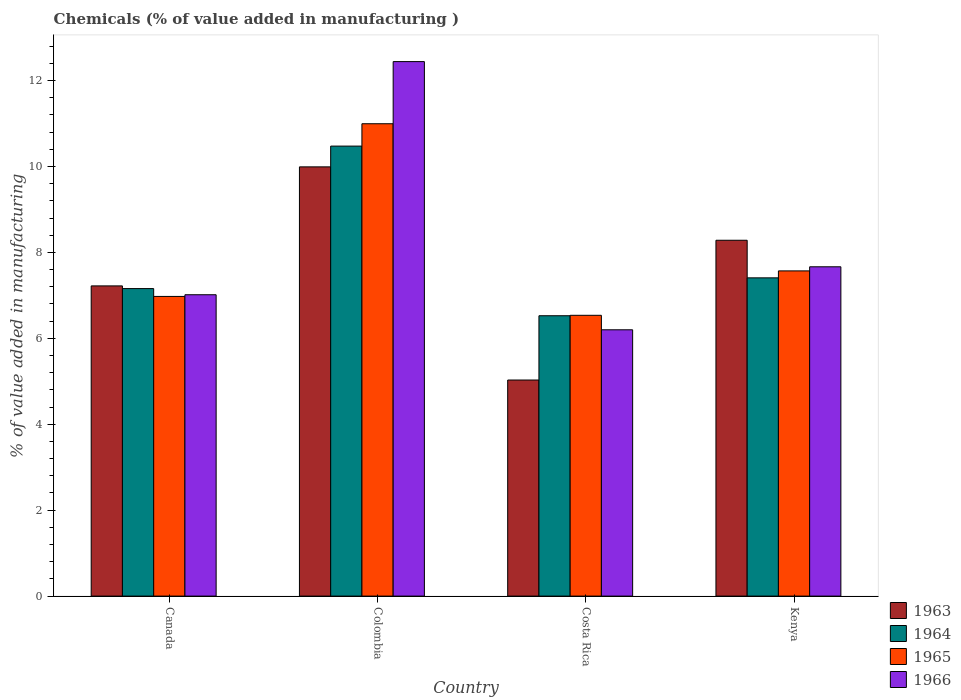How many groups of bars are there?
Keep it short and to the point. 4. How many bars are there on the 1st tick from the left?
Offer a terse response. 4. How many bars are there on the 1st tick from the right?
Your response must be concise. 4. What is the label of the 1st group of bars from the left?
Keep it short and to the point. Canada. What is the value added in manufacturing chemicals in 1964 in Colombia?
Your answer should be compact. 10.47. Across all countries, what is the maximum value added in manufacturing chemicals in 1966?
Provide a short and direct response. 12.44. Across all countries, what is the minimum value added in manufacturing chemicals in 1963?
Give a very brief answer. 5.03. In which country was the value added in manufacturing chemicals in 1964 maximum?
Provide a short and direct response. Colombia. In which country was the value added in manufacturing chemicals in 1963 minimum?
Give a very brief answer. Costa Rica. What is the total value added in manufacturing chemicals in 1966 in the graph?
Offer a very short reply. 33.32. What is the difference between the value added in manufacturing chemicals in 1964 in Canada and that in Colombia?
Make the answer very short. -3.32. What is the difference between the value added in manufacturing chemicals in 1966 in Costa Rica and the value added in manufacturing chemicals in 1965 in Colombia?
Make the answer very short. -4.8. What is the average value added in manufacturing chemicals in 1966 per country?
Provide a short and direct response. 8.33. What is the difference between the value added in manufacturing chemicals of/in 1964 and value added in manufacturing chemicals of/in 1963 in Canada?
Keep it short and to the point. -0.06. In how many countries, is the value added in manufacturing chemicals in 1964 greater than 3.2 %?
Your answer should be compact. 4. What is the ratio of the value added in manufacturing chemicals in 1964 in Colombia to that in Costa Rica?
Your response must be concise. 1.61. What is the difference between the highest and the second highest value added in manufacturing chemicals in 1963?
Your answer should be compact. -1.71. What is the difference between the highest and the lowest value added in manufacturing chemicals in 1966?
Provide a succinct answer. 6.24. In how many countries, is the value added in manufacturing chemicals in 1964 greater than the average value added in manufacturing chemicals in 1964 taken over all countries?
Your answer should be compact. 1. What does the 3rd bar from the left in Costa Rica represents?
Give a very brief answer. 1965. Where does the legend appear in the graph?
Give a very brief answer. Bottom right. What is the title of the graph?
Keep it short and to the point. Chemicals (% of value added in manufacturing ). What is the label or title of the X-axis?
Offer a terse response. Country. What is the label or title of the Y-axis?
Your answer should be compact. % of value added in manufacturing. What is the % of value added in manufacturing of 1963 in Canada?
Your response must be concise. 7.22. What is the % of value added in manufacturing of 1964 in Canada?
Keep it short and to the point. 7.16. What is the % of value added in manufacturing of 1965 in Canada?
Your answer should be very brief. 6.98. What is the % of value added in manufacturing in 1966 in Canada?
Offer a very short reply. 7.01. What is the % of value added in manufacturing of 1963 in Colombia?
Offer a very short reply. 9.99. What is the % of value added in manufacturing of 1964 in Colombia?
Your answer should be very brief. 10.47. What is the % of value added in manufacturing of 1965 in Colombia?
Your answer should be very brief. 10.99. What is the % of value added in manufacturing of 1966 in Colombia?
Keep it short and to the point. 12.44. What is the % of value added in manufacturing of 1963 in Costa Rica?
Your response must be concise. 5.03. What is the % of value added in manufacturing of 1964 in Costa Rica?
Your answer should be compact. 6.53. What is the % of value added in manufacturing in 1965 in Costa Rica?
Offer a very short reply. 6.54. What is the % of value added in manufacturing of 1966 in Costa Rica?
Your answer should be compact. 6.2. What is the % of value added in manufacturing in 1963 in Kenya?
Provide a short and direct response. 8.28. What is the % of value added in manufacturing in 1964 in Kenya?
Your answer should be very brief. 7.41. What is the % of value added in manufacturing in 1965 in Kenya?
Give a very brief answer. 7.57. What is the % of value added in manufacturing in 1966 in Kenya?
Give a very brief answer. 7.67. Across all countries, what is the maximum % of value added in manufacturing of 1963?
Make the answer very short. 9.99. Across all countries, what is the maximum % of value added in manufacturing of 1964?
Your answer should be compact. 10.47. Across all countries, what is the maximum % of value added in manufacturing in 1965?
Your response must be concise. 10.99. Across all countries, what is the maximum % of value added in manufacturing of 1966?
Your answer should be compact. 12.44. Across all countries, what is the minimum % of value added in manufacturing in 1963?
Make the answer very short. 5.03. Across all countries, what is the minimum % of value added in manufacturing in 1964?
Your answer should be very brief. 6.53. Across all countries, what is the minimum % of value added in manufacturing of 1965?
Your answer should be very brief. 6.54. Across all countries, what is the minimum % of value added in manufacturing in 1966?
Provide a short and direct response. 6.2. What is the total % of value added in manufacturing of 1963 in the graph?
Keep it short and to the point. 30.52. What is the total % of value added in manufacturing of 1964 in the graph?
Make the answer very short. 31.57. What is the total % of value added in manufacturing of 1965 in the graph?
Keep it short and to the point. 32.08. What is the total % of value added in manufacturing in 1966 in the graph?
Make the answer very short. 33.32. What is the difference between the % of value added in manufacturing in 1963 in Canada and that in Colombia?
Make the answer very short. -2.77. What is the difference between the % of value added in manufacturing of 1964 in Canada and that in Colombia?
Your answer should be very brief. -3.32. What is the difference between the % of value added in manufacturing of 1965 in Canada and that in Colombia?
Ensure brevity in your answer.  -4.02. What is the difference between the % of value added in manufacturing of 1966 in Canada and that in Colombia?
Make the answer very short. -5.43. What is the difference between the % of value added in manufacturing of 1963 in Canada and that in Costa Rica?
Make the answer very short. 2.19. What is the difference between the % of value added in manufacturing of 1964 in Canada and that in Costa Rica?
Ensure brevity in your answer.  0.63. What is the difference between the % of value added in manufacturing of 1965 in Canada and that in Costa Rica?
Your answer should be very brief. 0.44. What is the difference between the % of value added in manufacturing of 1966 in Canada and that in Costa Rica?
Your answer should be very brief. 0.82. What is the difference between the % of value added in manufacturing in 1963 in Canada and that in Kenya?
Your answer should be compact. -1.06. What is the difference between the % of value added in manufacturing of 1964 in Canada and that in Kenya?
Provide a short and direct response. -0.25. What is the difference between the % of value added in manufacturing in 1965 in Canada and that in Kenya?
Your answer should be very brief. -0.59. What is the difference between the % of value added in manufacturing in 1966 in Canada and that in Kenya?
Ensure brevity in your answer.  -0.65. What is the difference between the % of value added in manufacturing in 1963 in Colombia and that in Costa Rica?
Your answer should be very brief. 4.96. What is the difference between the % of value added in manufacturing in 1964 in Colombia and that in Costa Rica?
Provide a succinct answer. 3.95. What is the difference between the % of value added in manufacturing in 1965 in Colombia and that in Costa Rica?
Ensure brevity in your answer.  4.46. What is the difference between the % of value added in manufacturing in 1966 in Colombia and that in Costa Rica?
Your answer should be compact. 6.24. What is the difference between the % of value added in manufacturing of 1963 in Colombia and that in Kenya?
Make the answer very short. 1.71. What is the difference between the % of value added in manufacturing in 1964 in Colombia and that in Kenya?
Give a very brief answer. 3.07. What is the difference between the % of value added in manufacturing of 1965 in Colombia and that in Kenya?
Your answer should be very brief. 3.43. What is the difference between the % of value added in manufacturing in 1966 in Colombia and that in Kenya?
Give a very brief answer. 4.78. What is the difference between the % of value added in manufacturing of 1963 in Costa Rica and that in Kenya?
Your answer should be very brief. -3.25. What is the difference between the % of value added in manufacturing of 1964 in Costa Rica and that in Kenya?
Your response must be concise. -0.88. What is the difference between the % of value added in manufacturing of 1965 in Costa Rica and that in Kenya?
Your answer should be compact. -1.03. What is the difference between the % of value added in manufacturing of 1966 in Costa Rica and that in Kenya?
Ensure brevity in your answer.  -1.47. What is the difference between the % of value added in manufacturing of 1963 in Canada and the % of value added in manufacturing of 1964 in Colombia?
Provide a short and direct response. -3.25. What is the difference between the % of value added in manufacturing of 1963 in Canada and the % of value added in manufacturing of 1965 in Colombia?
Provide a succinct answer. -3.77. What is the difference between the % of value added in manufacturing of 1963 in Canada and the % of value added in manufacturing of 1966 in Colombia?
Give a very brief answer. -5.22. What is the difference between the % of value added in manufacturing of 1964 in Canada and the % of value added in manufacturing of 1965 in Colombia?
Keep it short and to the point. -3.84. What is the difference between the % of value added in manufacturing of 1964 in Canada and the % of value added in manufacturing of 1966 in Colombia?
Your answer should be compact. -5.28. What is the difference between the % of value added in manufacturing in 1965 in Canada and the % of value added in manufacturing in 1966 in Colombia?
Provide a short and direct response. -5.47. What is the difference between the % of value added in manufacturing of 1963 in Canada and the % of value added in manufacturing of 1964 in Costa Rica?
Your answer should be very brief. 0.69. What is the difference between the % of value added in manufacturing in 1963 in Canada and the % of value added in manufacturing in 1965 in Costa Rica?
Your answer should be compact. 0.68. What is the difference between the % of value added in manufacturing in 1963 in Canada and the % of value added in manufacturing in 1966 in Costa Rica?
Provide a succinct answer. 1.02. What is the difference between the % of value added in manufacturing in 1964 in Canada and the % of value added in manufacturing in 1965 in Costa Rica?
Offer a terse response. 0.62. What is the difference between the % of value added in manufacturing in 1964 in Canada and the % of value added in manufacturing in 1966 in Costa Rica?
Your response must be concise. 0.96. What is the difference between the % of value added in manufacturing of 1965 in Canada and the % of value added in manufacturing of 1966 in Costa Rica?
Make the answer very short. 0.78. What is the difference between the % of value added in manufacturing of 1963 in Canada and the % of value added in manufacturing of 1964 in Kenya?
Your answer should be very brief. -0.19. What is the difference between the % of value added in manufacturing in 1963 in Canada and the % of value added in manufacturing in 1965 in Kenya?
Keep it short and to the point. -0.35. What is the difference between the % of value added in manufacturing of 1963 in Canada and the % of value added in manufacturing of 1966 in Kenya?
Your answer should be compact. -0.44. What is the difference between the % of value added in manufacturing of 1964 in Canada and the % of value added in manufacturing of 1965 in Kenya?
Provide a short and direct response. -0.41. What is the difference between the % of value added in manufacturing in 1964 in Canada and the % of value added in manufacturing in 1966 in Kenya?
Ensure brevity in your answer.  -0.51. What is the difference between the % of value added in manufacturing of 1965 in Canada and the % of value added in manufacturing of 1966 in Kenya?
Give a very brief answer. -0.69. What is the difference between the % of value added in manufacturing of 1963 in Colombia and the % of value added in manufacturing of 1964 in Costa Rica?
Offer a very short reply. 3.47. What is the difference between the % of value added in manufacturing of 1963 in Colombia and the % of value added in manufacturing of 1965 in Costa Rica?
Provide a short and direct response. 3.46. What is the difference between the % of value added in manufacturing of 1963 in Colombia and the % of value added in manufacturing of 1966 in Costa Rica?
Give a very brief answer. 3.79. What is the difference between the % of value added in manufacturing of 1964 in Colombia and the % of value added in manufacturing of 1965 in Costa Rica?
Ensure brevity in your answer.  3.94. What is the difference between the % of value added in manufacturing of 1964 in Colombia and the % of value added in manufacturing of 1966 in Costa Rica?
Provide a succinct answer. 4.28. What is the difference between the % of value added in manufacturing in 1965 in Colombia and the % of value added in manufacturing in 1966 in Costa Rica?
Your answer should be very brief. 4.8. What is the difference between the % of value added in manufacturing of 1963 in Colombia and the % of value added in manufacturing of 1964 in Kenya?
Your answer should be very brief. 2.58. What is the difference between the % of value added in manufacturing of 1963 in Colombia and the % of value added in manufacturing of 1965 in Kenya?
Make the answer very short. 2.42. What is the difference between the % of value added in manufacturing in 1963 in Colombia and the % of value added in manufacturing in 1966 in Kenya?
Provide a short and direct response. 2.33. What is the difference between the % of value added in manufacturing of 1964 in Colombia and the % of value added in manufacturing of 1965 in Kenya?
Your response must be concise. 2.9. What is the difference between the % of value added in manufacturing in 1964 in Colombia and the % of value added in manufacturing in 1966 in Kenya?
Your response must be concise. 2.81. What is the difference between the % of value added in manufacturing of 1965 in Colombia and the % of value added in manufacturing of 1966 in Kenya?
Make the answer very short. 3.33. What is the difference between the % of value added in manufacturing of 1963 in Costa Rica and the % of value added in manufacturing of 1964 in Kenya?
Your response must be concise. -2.38. What is the difference between the % of value added in manufacturing of 1963 in Costa Rica and the % of value added in manufacturing of 1965 in Kenya?
Your answer should be very brief. -2.54. What is the difference between the % of value added in manufacturing in 1963 in Costa Rica and the % of value added in manufacturing in 1966 in Kenya?
Provide a short and direct response. -2.64. What is the difference between the % of value added in manufacturing of 1964 in Costa Rica and the % of value added in manufacturing of 1965 in Kenya?
Keep it short and to the point. -1.04. What is the difference between the % of value added in manufacturing of 1964 in Costa Rica and the % of value added in manufacturing of 1966 in Kenya?
Keep it short and to the point. -1.14. What is the difference between the % of value added in manufacturing of 1965 in Costa Rica and the % of value added in manufacturing of 1966 in Kenya?
Your response must be concise. -1.13. What is the average % of value added in manufacturing of 1963 per country?
Give a very brief answer. 7.63. What is the average % of value added in manufacturing of 1964 per country?
Your answer should be very brief. 7.89. What is the average % of value added in manufacturing of 1965 per country?
Keep it short and to the point. 8.02. What is the average % of value added in manufacturing in 1966 per country?
Keep it short and to the point. 8.33. What is the difference between the % of value added in manufacturing in 1963 and % of value added in manufacturing in 1964 in Canada?
Provide a succinct answer. 0.06. What is the difference between the % of value added in manufacturing in 1963 and % of value added in manufacturing in 1965 in Canada?
Provide a short and direct response. 0.25. What is the difference between the % of value added in manufacturing in 1963 and % of value added in manufacturing in 1966 in Canada?
Provide a short and direct response. 0.21. What is the difference between the % of value added in manufacturing of 1964 and % of value added in manufacturing of 1965 in Canada?
Your response must be concise. 0.18. What is the difference between the % of value added in manufacturing in 1964 and % of value added in manufacturing in 1966 in Canada?
Offer a terse response. 0.14. What is the difference between the % of value added in manufacturing of 1965 and % of value added in manufacturing of 1966 in Canada?
Offer a terse response. -0.04. What is the difference between the % of value added in manufacturing of 1963 and % of value added in manufacturing of 1964 in Colombia?
Offer a terse response. -0.48. What is the difference between the % of value added in manufacturing in 1963 and % of value added in manufacturing in 1965 in Colombia?
Your response must be concise. -1. What is the difference between the % of value added in manufacturing of 1963 and % of value added in manufacturing of 1966 in Colombia?
Make the answer very short. -2.45. What is the difference between the % of value added in manufacturing of 1964 and % of value added in manufacturing of 1965 in Colombia?
Provide a succinct answer. -0.52. What is the difference between the % of value added in manufacturing in 1964 and % of value added in manufacturing in 1966 in Colombia?
Provide a short and direct response. -1.97. What is the difference between the % of value added in manufacturing of 1965 and % of value added in manufacturing of 1966 in Colombia?
Your answer should be compact. -1.45. What is the difference between the % of value added in manufacturing of 1963 and % of value added in manufacturing of 1964 in Costa Rica?
Provide a short and direct response. -1.5. What is the difference between the % of value added in manufacturing of 1963 and % of value added in manufacturing of 1965 in Costa Rica?
Keep it short and to the point. -1.51. What is the difference between the % of value added in manufacturing in 1963 and % of value added in manufacturing in 1966 in Costa Rica?
Offer a very short reply. -1.17. What is the difference between the % of value added in manufacturing of 1964 and % of value added in manufacturing of 1965 in Costa Rica?
Ensure brevity in your answer.  -0.01. What is the difference between the % of value added in manufacturing in 1964 and % of value added in manufacturing in 1966 in Costa Rica?
Offer a terse response. 0.33. What is the difference between the % of value added in manufacturing of 1965 and % of value added in manufacturing of 1966 in Costa Rica?
Your answer should be very brief. 0.34. What is the difference between the % of value added in manufacturing in 1963 and % of value added in manufacturing in 1964 in Kenya?
Offer a terse response. 0.87. What is the difference between the % of value added in manufacturing of 1963 and % of value added in manufacturing of 1965 in Kenya?
Give a very brief answer. 0.71. What is the difference between the % of value added in manufacturing of 1963 and % of value added in manufacturing of 1966 in Kenya?
Keep it short and to the point. 0.62. What is the difference between the % of value added in manufacturing of 1964 and % of value added in manufacturing of 1965 in Kenya?
Offer a terse response. -0.16. What is the difference between the % of value added in manufacturing of 1964 and % of value added in manufacturing of 1966 in Kenya?
Keep it short and to the point. -0.26. What is the difference between the % of value added in manufacturing of 1965 and % of value added in manufacturing of 1966 in Kenya?
Offer a very short reply. -0.1. What is the ratio of the % of value added in manufacturing of 1963 in Canada to that in Colombia?
Your response must be concise. 0.72. What is the ratio of the % of value added in manufacturing of 1964 in Canada to that in Colombia?
Make the answer very short. 0.68. What is the ratio of the % of value added in manufacturing in 1965 in Canada to that in Colombia?
Ensure brevity in your answer.  0.63. What is the ratio of the % of value added in manufacturing of 1966 in Canada to that in Colombia?
Your answer should be very brief. 0.56. What is the ratio of the % of value added in manufacturing in 1963 in Canada to that in Costa Rica?
Offer a very short reply. 1.44. What is the ratio of the % of value added in manufacturing in 1964 in Canada to that in Costa Rica?
Offer a terse response. 1.1. What is the ratio of the % of value added in manufacturing in 1965 in Canada to that in Costa Rica?
Keep it short and to the point. 1.07. What is the ratio of the % of value added in manufacturing of 1966 in Canada to that in Costa Rica?
Provide a succinct answer. 1.13. What is the ratio of the % of value added in manufacturing in 1963 in Canada to that in Kenya?
Provide a short and direct response. 0.87. What is the ratio of the % of value added in manufacturing of 1964 in Canada to that in Kenya?
Offer a terse response. 0.97. What is the ratio of the % of value added in manufacturing in 1965 in Canada to that in Kenya?
Your answer should be very brief. 0.92. What is the ratio of the % of value added in manufacturing in 1966 in Canada to that in Kenya?
Offer a terse response. 0.92. What is the ratio of the % of value added in manufacturing of 1963 in Colombia to that in Costa Rica?
Make the answer very short. 1.99. What is the ratio of the % of value added in manufacturing in 1964 in Colombia to that in Costa Rica?
Offer a terse response. 1.61. What is the ratio of the % of value added in manufacturing of 1965 in Colombia to that in Costa Rica?
Offer a terse response. 1.68. What is the ratio of the % of value added in manufacturing in 1966 in Colombia to that in Costa Rica?
Keep it short and to the point. 2.01. What is the ratio of the % of value added in manufacturing in 1963 in Colombia to that in Kenya?
Make the answer very short. 1.21. What is the ratio of the % of value added in manufacturing in 1964 in Colombia to that in Kenya?
Your answer should be very brief. 1.41. What is the ratio of the % of value added in manufacturing in 1965 in Colombia to that in Kenya?
Your answer should be compact. 1.45. What is the ratio of the % of value added in manufacturing of 1966 in Colombia to that in Kenya?
Ensure brevity in your answer.  1.62. What is the ratio of the % of value added in manufacturing in 1963 in Costa Rica to that in Kenya?
Your answer should be compact. 0.61. What is the ratio of the % of value added in manufacturing of 1964 in Costa Rica to that in Kenya?
Provide a succinct answer. 0.88. What is the ratio of the % of value added in manufacturing of 1965 in Costa Rica to that in Kenya?
Make the answer very short. 0.86. What is the ratio of the % of value added in manufacturing of 1966 in Costa Rica to that in Kenya?
Make the answer very short. 0.81. What is the difference between the highest and the second highest % of value added in manufacturing of 1963?
Offer a very short reply. 1.71. What is the difference between the highest and the second highest % of value added in manufacturing in 1964?
Make the answer very short. 3.07. What is the difference between the highest and the second highest % of value added in manufacturing in 1965?
Offer a terse response. 3.43. What is the difference between the highest and the second highest % of value added in manufacturing in 1966?
Offer a very short reply. 4.78. What is the difference between the highest and the lowest % of value added in manufacturing in 1963?
Make the answer very short. 4.96. What is the difference between the highest and the lowest % of value added in manufacturing in 1964?
Keep it short and to the point. 3.95. What is the difference between the highest and the lowest % of value added in manufacturing of 1965?
Keep it short and to the point. 4.46. What is the difference between the highest and the lowest % of value added in manufacturing in 1966?
Give a very brief answer. 6.24. 